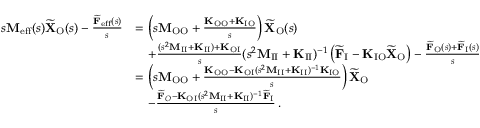Convert formula to latex. <formula><loc_0><loc_0><loc_500><loc_500>\begin{array} { r l } { s M _ { e f f } ( s ) \widetilde { X } _ { O } ( s ) - \frac { \widetilde { F } _ { e f f } ( s ) } { s } } & { = \left ( s M _ { O O } + \frac { K _ { O O } + K _ { I O } } { s } \right ) \widetilde { X } _ { O } ( s ) } \\ & { \quad + \frac { ( s ^ { 2 } M _ { I I } + K _ { I I } ) + K _ { O I } } { s } ( s ^ { 2 } M _ { I I } + K _ { I I } ) ^ { - 1 } \left ( \widetilde { F } _ { I } - K _ { I O } \widetilde { X } _ { O } \right ) - \frac { \widetilde { F } _ { O } ( s ) + \widetilde { F } _ { I } ( s ) } { s } } \\ & { = \left ( s M _ { O O } + \frac { K _ { O O } - K _ { O I } ( s ^ { 2 } M _ { I I } + K _ { I I } ) ^ { - 1 } K _ { I O } } { s } \right ) \widetilde { X } _ { O } } \\ & { \quad - \frac { \widetilde { F } _ { O } - K _ { O I } ( s ^ { 2 } M _ { I I } + K _ { I I } ) ^ { - 1 } \widetilde { F } _ { I } } { s } \, . } \end{array}</formula> 